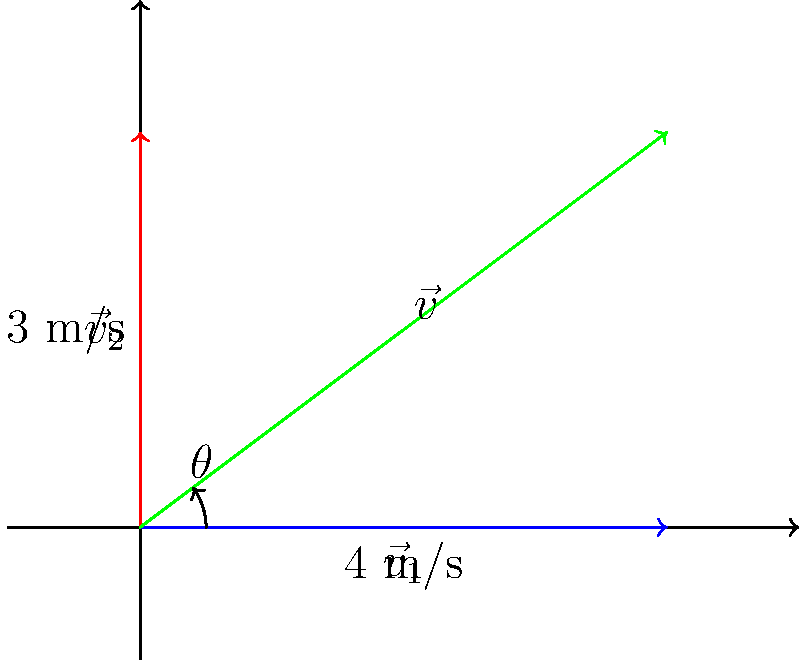As the head of the department approving airport construction projects, you're analyzing the impact of crosswinds on landing trajectories. An aircraft is approaching a runway with a headwind of 4 m/s and a crosswind of 3 m/s. Using vector decomposition, calculate the magnitude of the resultant wind vector and its angle relative to the runway direction. To solve this problem, we'll use vector addition and the Pythagorean theorem:

1) Let $\vec{v}_1$ be the headwind vector (4 m/s along the runway) and $\vec{v}_2$ be the crosswind vector (3 m/s perpendicular to the runway).

2) The resultant wind vector $\vec{v}$ is the sum of these two vectors: $\vec{v} = \vec{v}_1 + \vec{v}_2$

3) To find the magnitude of $\vec{v}$, we use the Pythagorean theorem:

   $\|\vec{v}\| = \sqrt{(\|\vec{v}_1\|)^2 + (\|\vec{v}_2\|)^2} = \sqrt{4^2 + 3^2} = \sqrt{16 + 9} = \sqrt{25} = 5$ m/s

4) To find the angle $\theta$ between $\vec{v}$ and the runway direction, we use the arctangent function:

   $\theta = \arctan(\frac{\|\vec{v}_2\|}{\|\vec{v}_1\|}) = \arctan(\frac{3}{4}) \approx 36.87°$

Therefore, the resultant wind vector has a magnitude of 5 m/s and makes an angle of approximately 36.87° with the runway direction.
Answer: 5 m/s, 36.87° 